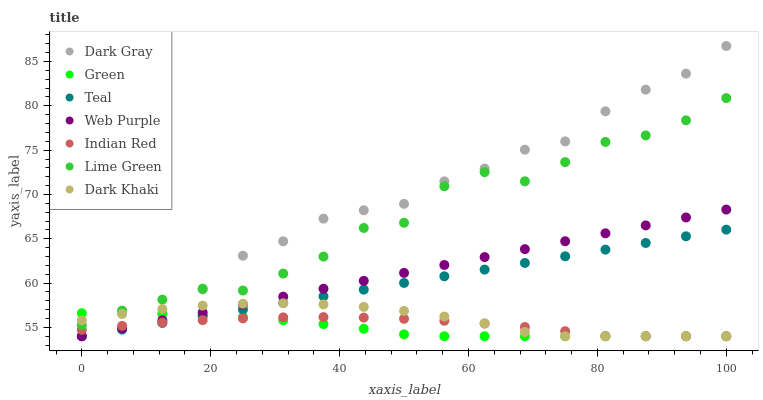Does Green have the minimum area under the curve?
Answer yes or no. Yes. Does Dark Gray have the maximum area under the curve?
Answer yes or no. Yes. Does Teal have the minimum area under the curve?
Answer yes or no. No. Does Teal have the maximum area under the curve?
Answer yes or no. No. Is Teal the smoothest?
Answer yes or no. Yes. Is Lime Green the roughest?
Answer yes or no. Yes. Is Dark Gray the smoothest?
Answer yes or no. No. Is Dark Gray the roughest?
Answer yes or no. No. Does Dark Khaki have the lowest value?
Answer yes or no. Yes. Does Lime Green have the lowest value?
Answer yes or no. No. Does Dark Gray have the highest value?
Answer yes or no. Yes. Does Teal have the highest value?
Answer yes or no. No. Is Teal less than Lime Green?
Answer yes or no. Yes. Is Lime Green greater than Web Purple?
Answer yes or no. Yes. Does Green intersect Indian Red?
Answer yes or no. Yes. Is Green less than Indian Red?
Answer yes or no. No. Is Green greater than Indian Red?
Answer yes or no. No. Does Teal intersect Lime Green?
Answer yes or no. No. 